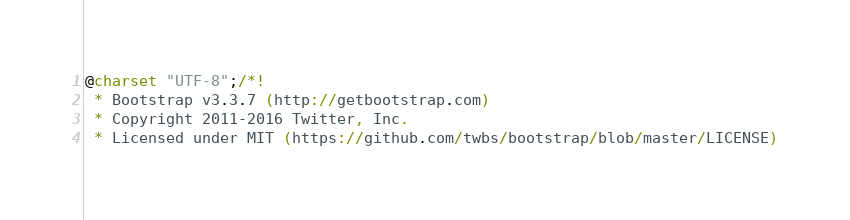Convert code to text. <code><loc_0><loc_0><loc_500><loc_500><_CSS_>@charset "UTF-8";/*!
 * Bootstrap v3.3.7 (http://getbootstrap.com)
 * Copyright 2011-2016 Twitter, Inc.
 * Licensed under MIT (https://github.com/twbs/bootstrap/blob/master/LICENSE)</code> 